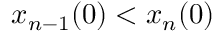Convert formula to latex. <formula><loc_0><loc_0><loc_500><loc_500>x _ { n - 1 } ( 0 ) < x _ { n } ( 0 )</formula> 